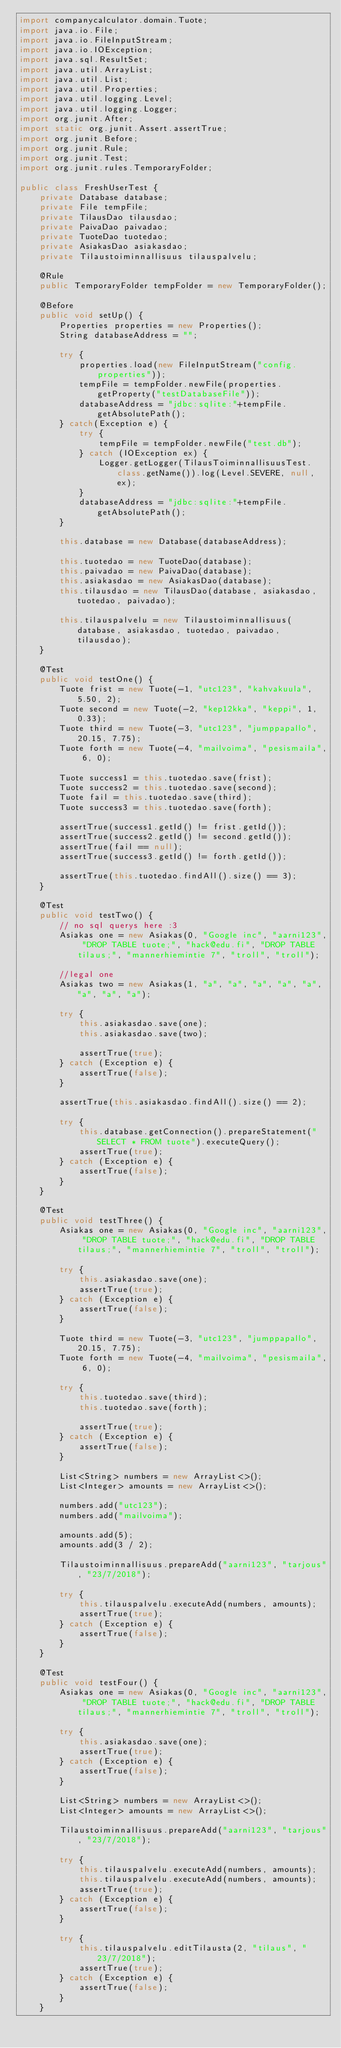<code> <loc_0><loc_0><loc_500><loc_500><_Java_>import companycalculator.domain.Tuote;
import java.io.File;
import java.io.FileInputStream;
import java.io.IOException;
import java.sql.ResultSet;
import java.util.ArrayList;
import java.util.List;
import java.util.Properties;
import java.util.logging.Level;
import java.util.logging.Logger;
import org.junit.After;
import static org.junit.Assert.assertTrue;
import org.junit.Before;
import org.junit.Rule;
import org.junit.Test;
import org.junit.rules.TemporaryFolder;

public class FreshUserTest {
    private Database database;
    private File tempFile;
    private TilausDao tilausdao;
    private PaivaDao paivadao;
    private TuoteDao tuotedao;
    private AsiakasDao asiakasdao;
    private Tilaustoiminnallisuus tilauspalvelu;
    
    @Rule
    public TemporaryFolder tempFolder = new TemporaryFolder();

    @Before
    public void setUp() {
        Properties properties = new Properties();
        String databaseAddress = "";
        
        try {
            properties.load(new FileInputStream("config.properties"));
            tempFile = tempFolder.newFile(properties.getProperty("testDatabaseFile"));
            databaseAddress = "jdbc:sqlite:"+tempFile.getAbsolutePath();
        } catch(Exception e) {
            try {
                tempFile = tempFolder.newFile("test.db");
            } catch (IOException ex) {
                Logger.getLogger(TilausToiminnallisuusTest.class.getName()).log(Level.SEVERE, null, ex);
            }
            databaseAddress = "jdbc:sqlite:"+tempFile.getAbsolutePath();
        }
        
        this.database = new Database(databaseAddress);
        
        this.tuotedao = new TuoteDao(database);
        this.paivadao = new PaivaDao(database);
        this.asiakasdao = new AsiakasDao(database);
        this.tilausdao = new TilausDao(database, asiakasdao, tuotedao, paivadao);

        this.tilauspalvelu = new Tilaustoiminnallisuus(database, asiakasdao, tuotedao, paivadao, tilausdao);
    }
    
    @Test
    public void testOne() {
        Tuote frist = new Tuote(-1, "utc123", "kahvakuula", 5.50, 2);
        Tuote second = new Tuote(-2, "kep12kka", "keppi", 1, 0.33);
        Tuote third = new Tuote(-3, "utc123", "jumppapallo", 20.15, 7.75);
        Tuote forth = new Tuote(-4, "mailvoima", "pesismaila", 6, 0);
        
        Tuote success1 = this.tuotedao.save(frist);
        Tuote success2 = this.tuotedao.save(second);
        Tuote fail = this.tuotedao.save(third);
        Tuote success3 = this.tuotedao.save(forth);
        
        assertTrue(success1.getId() != frist.getId());
        assertTrue(success2.getId() != second.getId());
        assertTrue(fail == null);
        assertTrue(success3.getId() != forth.getId());
        
        assertTrue(this.tuotedao.findAll().size() == 3);
    }
    
    @Test
    public void testTwo() {
        // no sql querys here :3
        Asiakas one = new Asiakas(0, "Google inc", "aarni123", "DROP TABLE tuote;", "hack@edu.fi", "DROP TABLE tilaus;", "mannerhiemintie 7", "troll", "troll");
        
        //legal one
        Asiakas two = new Asiakas(1, "a", "a", "a", "a", "a", "a", "a", "a");
        
        try {
            this.asiakasdao.save(one);
            this.asiakasdao.save(two);
            
            assertTrue(true);
        } catch (Exception e) {
            assertTrue(false);
        }
        
        assertTrue(this.asiakasdao.findAll().size() == 2);
        
        try {
            this.database.getConnection().prepareStatement("SELECT * FROM tuote").executeQuery();
            assertTrue(true);
        } catch (Exception e) {
            assertTrue(false);
        }
    }
    
    @Test
    public void testThree() {
        Asiakas one = new Asiakas(0, "Google inc", "aarni123", "DROP TABLE tuote;", "hack@edu.fi", "DROP TABLE tilaus;", "mannerhiemintie 7", "troll", "troll");
        
        try {
            this.asiakasdao.save(one);
            assertTrue(true);
        } catch (Exception e) {
            assertTrue(false);
        }
        
        Tuote third = new Tuote(-3, "utc123", "jumppapallo", 20.15, 7.75);
        Tuote forth = new Tuote(-4, "mailvoima", "pesismaila", 6, 0);
        
        try {
            this.tuotedao.save(third);
            this.tuotedao.save(forth);
            
            assertTrue(true);
        } catch (Exception e) {
            assertTrue(false);
        }
        
        List<String> numbers = new ArrayList<>();
        List<Integer> amounts = new ArrayList<>();
        
        numbers.add("utc123");
        numbers.add("mailvoima");
        
        amounts.add(5);
        amounts.add(3 / 2);
        
        Tilaustoiminnallisuus.prepareAdd("aarni123", "tarjous", "23/7/2018");
        
        try {
            this.tilauspalvelu.executeAdd(numbers, amounts);
            assertTrue(true);
        } catch (Exception e) {
            assertTrue(false);
        }
    }
    
    @Test
    public void testFour() {
        Asiakas one = new Asiakas(0, "Google inc", "aarni123", "DROP TABLE tuote;", "hack@edu.fi", "DROP TABLE tilaus;", "mannerhiemintie 7", "troll", "troll");
        
        try {
            this.asiakasdao.save(one);
            assertTrue(true);
        } catch (Exception e) {
            assertTrue(false);
        }
        
        List<String> numbers = new ArrayList<>();
        List<Integer> amounts = new ArrayList<>();
        
        Tilaustoiminnallisuus.prepareAdd("aarni123", "tarjous", "23/7/2018");
        
        try {
            this.tilauspalvelu.executeAdd(numbers, amounts);
            this.tilauspalvelu.executeAdd(numbers, amounts);
            assertTrue(true);
        } catch (Exception e) {
            assertTrue(false);
        }
        
        try {
            this.tilauspalvelu.editTilausta(2, "tilaus", "23/7/2018");
            assertTrue(true);
        } catch (Exception e) {
            assertTrue(false);
        }
    }</code> 